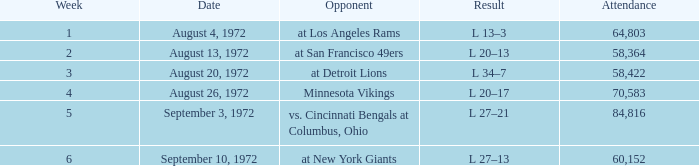In how many weeks was the attendance greater than 84,816? 0.0. Would you mind parsing the complete table? {'header': ['Week', 'Date', 'Opponent', 'Result', 'Attendance'], 'rows': [['1', 'August 4, 1972', 'at Los Angeles Rams', 'L 13–3', '64,803'], ['2', 'August 13, 1972', 'at San Francisco 49ers', 'L 20–13', '58,364'], ['3', 'August 20, 1972', 'at Detroit Lions', 'L 34–7', '58,422'], ['4', 'August 26, 1972', 'Minnesota Vikings', 'L 20–17', '70,583'], ['5', 'September 3, 1972', 'vs. Cincinnati Bengals at Columbus, Ohio', 'L 27–21', '84,816'], ['6', 'September 10, 1972', 'at New York Giants', 'L 27–13', '60,152']]} 